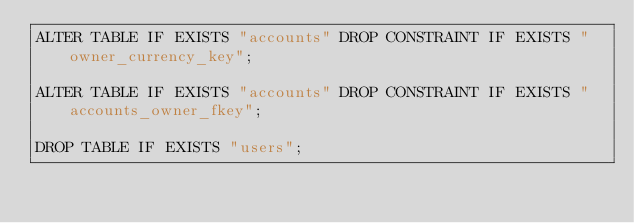<code> <loc_0><loc_0><loc_500><loc_500><_SQL_>ALTER TABLE IF EXISTS "accounts" DROP CONSTRAINT IF EXISTS "owner_currency_key";

ALTER TABLE IF EXISTS "accounts" DROP CONSTRAINT IF EXISTS "accounts_owner_fkey";

DROP TABLE IF EXISTS "users";</code> 